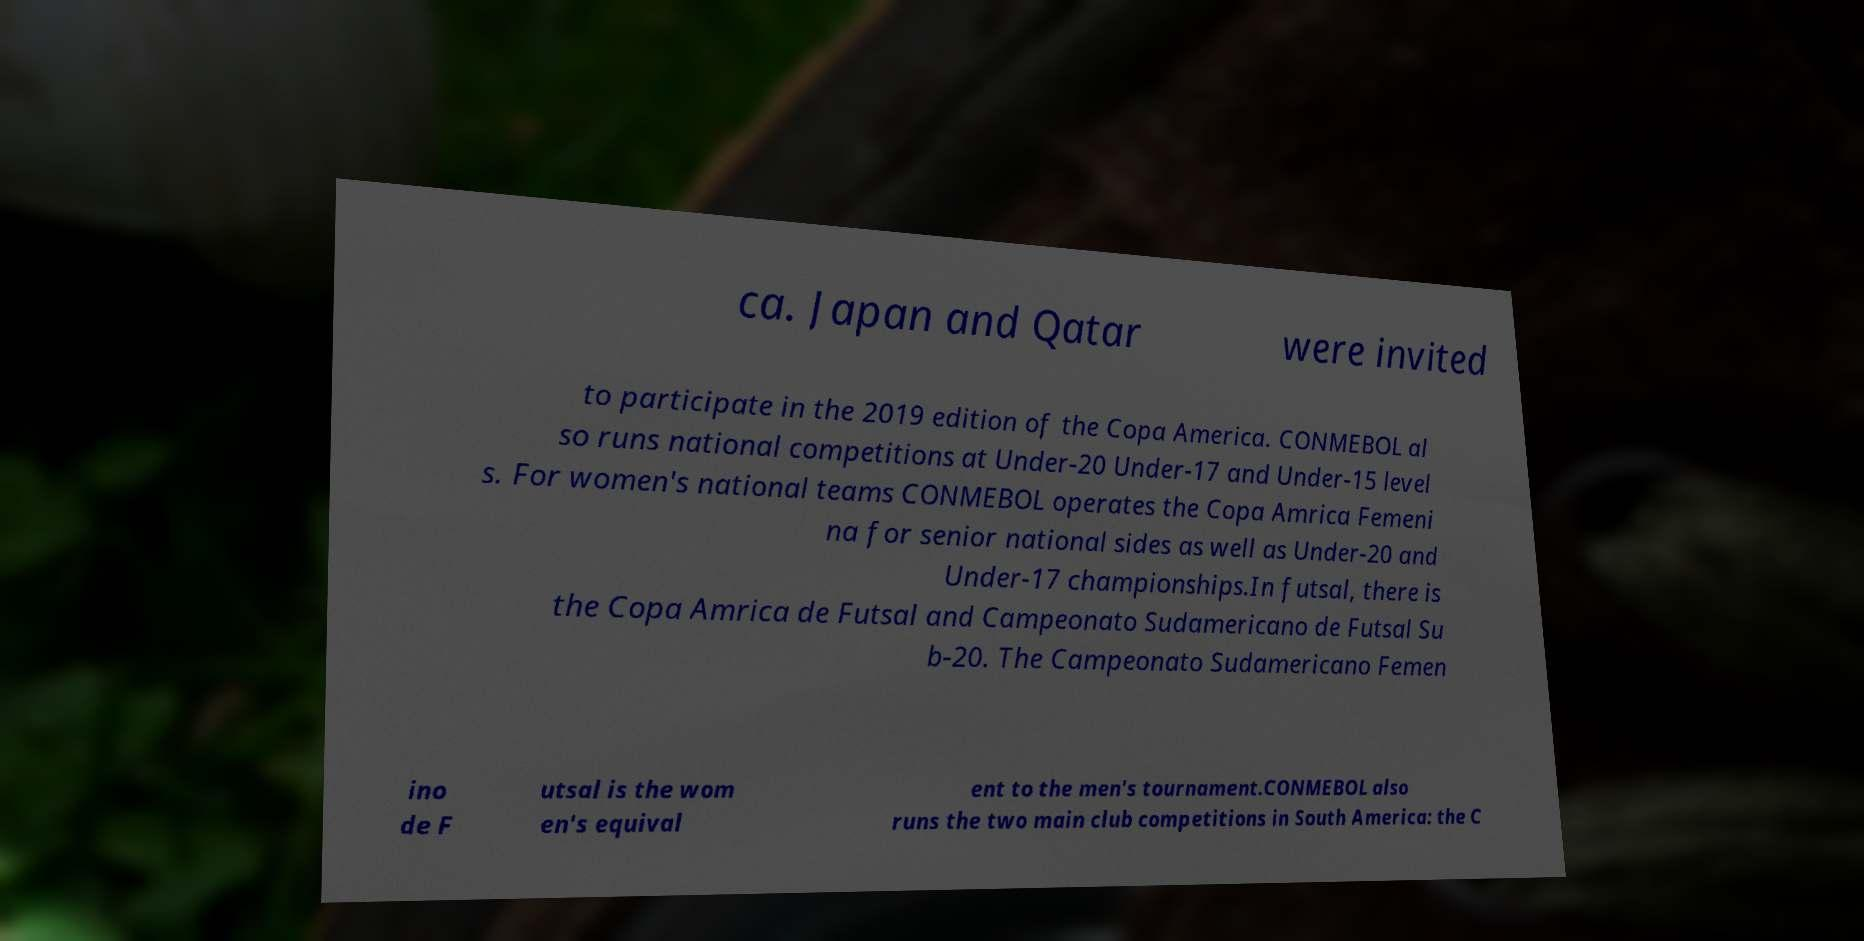Could you extract and type out the text from this image? ca. Japan and Qatar were invited to participate in the 2019 edition of the Copa America. CONMEBOL al so runs national competitions at Under-20 Under-17 and Under-15 level s. For women's national teams CONMEBOL operates the Copa Amrica Femeni na for senior national sides as well as Under-20 and Under-17 championships.In futsal, there is the Copa Amrica de Futsal and Campeonato Sudamericano de Futsal Su b-20. The Campeonato Sudamericano Femen ino de F utsal is the wom en's equival ent to the men's tournament.CONMEBOL also runs the two main club competitions in South America: the C 